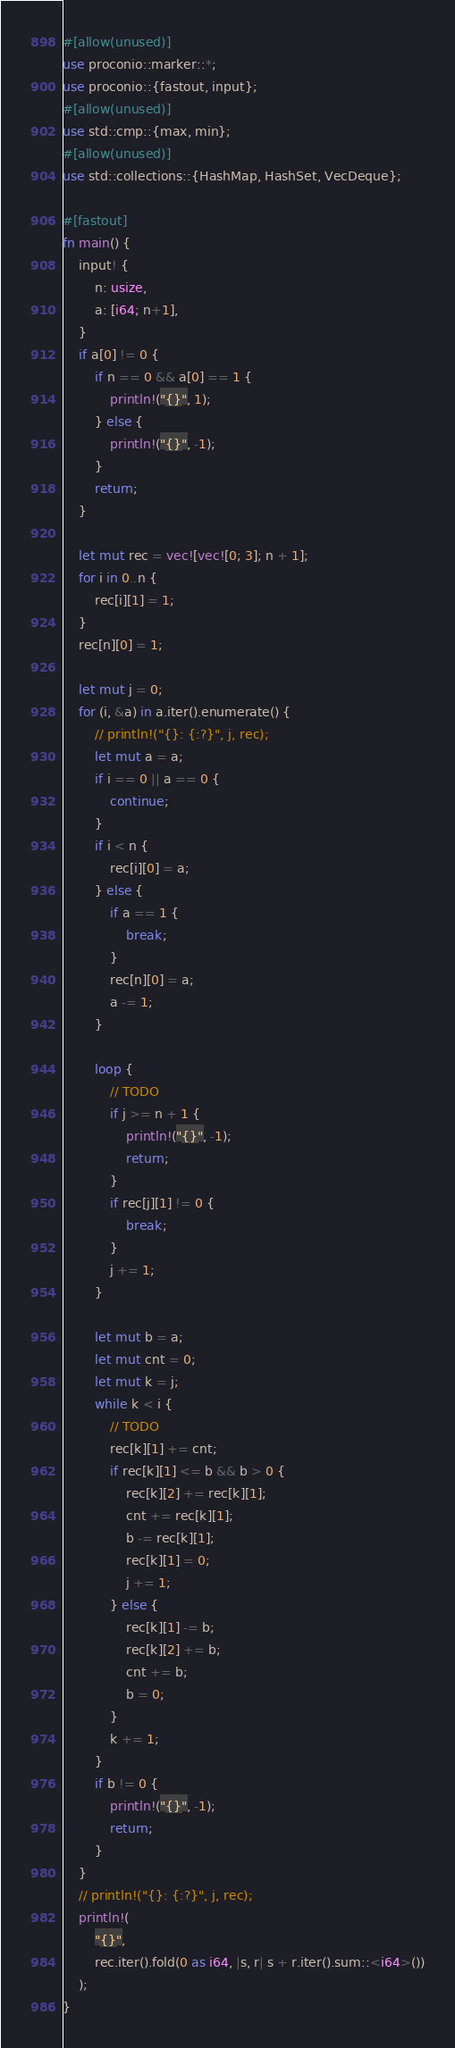Convert code to text. <code><loc_0><loc_0><loc_500><loc_500><_Rust_>#[allow(unused)]
use proconio::marker::*;
use proconio::{fastout, input};
#[allow(unused)]
use std::cmp::{max, min};
#[allow(unused)]
use std::collections::{HashMap, HashSet, VecDeque};

#[fastout]
fn main() {
    input! {
        n: usize,
        a: [i64; n+1],
    }
    if a[0] != 0 {
        if n == 0 && a[0] == 1 {
            println!("{}", 1);
        } else {
            println!("{}", -1);
        }
        return;
    }

    let mut rec = vec![vec![0; 3]; n + 1];
    for i in 0..n {
        rec[i][1] = 1;
    }
    rec[n][0] = 1;

    let mut j = 0;
    for (i, &a) in a.iter().enumerate() {
        // println!("{}: {:?}", j, rec);
        let mut a = a;
        if i == 0 || a == 0 {
            continue;
        }
        if i < n {
            rec[i][0] = a;
        } else {
            if a == 1 {
                break;
            }
            rec[n][0] = a;
            a -= 1;
        }

        loop {
            // TODO
            if j >= n + 1 {
                println!("{}", -1);
                return;
            }
            if rec[j][1] != 0 {
                break;
            }
            j += 1;
        }

        let mut b = a;
        let mut cnt = 0;
        let mut k = j;
        while k < i {
            // TODO
            rec[k][1] += cnt;
            if rec[k][1] <= b && b > 0 {
                rec[k][2] += rec[k][1];
                cnt += rec[k][1];
                b -= rec[k][1];
                rec[k][1] = 0;
                j += 1;
            } else {
                rec[k][1] -= b;
                rec[k][2] += b;
                cnt += b;
                b = 0;
            }
            k += 1;
        }
        if b != 0 {
            println!("{}", -1);
            return;
        }
    }
    // println!("{}: {:?}", j, rec);
    println!(
        "{}",
        rec.iter().fold(0 as i64, |s, r| s + r.iter().sum::<i64>())
    );
}
</code> 